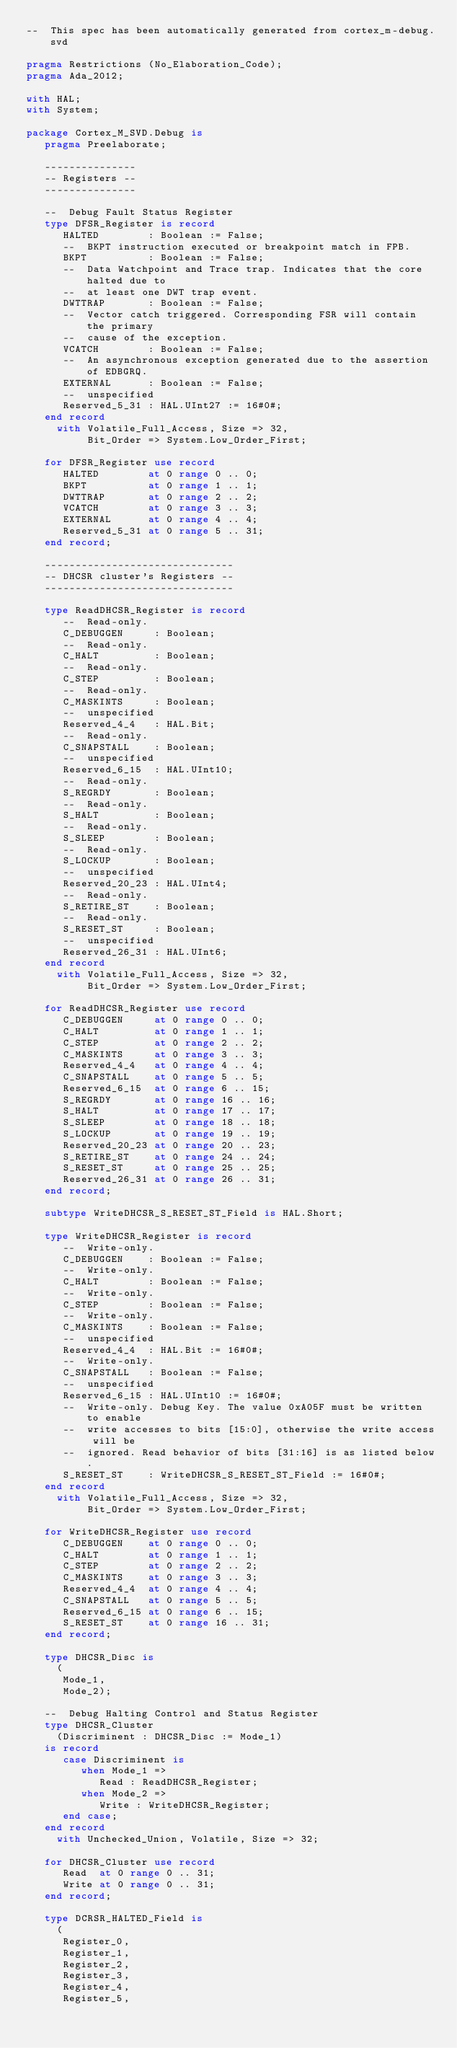Convert code to text. <code><loc_0><loc_0><loc_500><loc_500><_Ada_>--  This spec has been automatically generated from cortex_m-debug.svd

pragma Restrictions (No_Elaboration_Code);
pragma Ada_2012;

with HAL;
with System;

package Cortex_M_SVD.Debug is
   pragma Preelaborate;

   ---------------
   -- Registers --
   ---------------

   --  Debug Fault Status Register
   type DFSR_Register is record
      HALTED        : Boolean := False;
      --  BKPT instruction executed or breakpoint match in FPB.
      BKPT          : Boolean := False;
      --  Data Watchpoint and Trace trap. Indicates that the core halted due to
      --  at least one DWT trap event.
      DWTTRAP       : Boolean := False;
      --  Vector catch triggered. Corresponding FSR will contain the primary
      --  cause of the exception.
      VCATCH        : Boolean := False;
      --  An asynchronous exception generated due to the assertion of EDBGRQ.
      EXTERNAL      : Boolean := False;
      --  unspecified
      Reserved_5_31 : HAL.UInt27 := 16#0#;
   end record
     with Volatile_Full_Access, Size => 32,
          Bit_Order => System.Low_Order_First;

   for DFSR_Register use record
      HALTED        at 0 range 0 .. 0;
      BKPT          at 0 range 1 .. 1;
      DWTTRAP       at 0 range 2 .. 2;
      VCATCH        at 0 range 3 .. 3;
      EXTERNAL      at 0 range 4 .. 4;
      Reserved_5_31 at 0 range 5 .. 31;
   end record;

   -------------------------------
   -- DHCSR cluster's Registers --
   -------------------------------

   type ReadDHCSR_Register is record
      --  Read-only.
      C_DEBUGGEN     : Boolean;
      --  Read-only.
      C_HALT         : Boolean;
      --  Read-only.
      C_STEP         : Boolean;
      --  Read-only.
      C_MASKINTS     : Boolean;
      --  unspecified
      Reserved_4_4   : HAL.Bit;
      --  Read-only.
      C_SNAPSTALL    : Boolean;
      --  unspecified
      Reserved_6_15  : HAL.UInt10;
      --  Read-only.
      S_REGRDY       : Boolean;
      --  Read-only.
      S_HALT         : Boolean;
      --  Read-only.
      S_SLEEP        : Boolean;
      --  Read-only.
      S_LOCKUP       : Boolean;
      --  unspecified
      Reserved_20_23 : HAL.UInt4;
      --  Read-only.
      S_RETIRE_ST    : Boolean;
      --  Read-only.
      S_RESET_ST     : Boolean;
      --  unspecified
      Reserved_26_31 : HAL.UInt6;
   end record
     with Volatile_Full_Access, Size => 32,
          Bit_Order => System.Low_Order_First;

   for ReadDHCSR_Register use record
      C_DEBUGGEN     at 0 range 0 .. 0;
      C_HALT         at 0 range 1 .. 1;
      C_STEP         at 0 range 2 .. 2;
      C_MASKINTS     at 0 range 3 .. 3;
      Reserved_4_4   at 0 range 4 .. 4;
      C_SNAPSTALL    at 0 range 5 .. 5;
      Reserved_6_15  at 0 range 6 .. 15;
      S_REGRDY       at 0 range 16 .. 16;
      S_HALT         at 0 range 17 .. 17;
      S_SLEEP        at 0 range 18 .. 18;
      S_LOCKUP       at 0 range 19 .. 19;
      Reserved_20_23 at 0 range 20 .. 23;
      S_RETIRE_ST    at 0 range 24 .. 24;
      S_RESET_ST     at 0 range 25 .. 25;
      Reserved_26_31 at 0 range 26 .. 31;
   end record;

   subtype WriteDHCSR_S_RESET_ST_Field is HAL.Short;

   type WriteDHCSR_Register is record
      --  Write-only.
      C_DEBUGGEN    : Boolean := False;
      --  Write-only.
      C_HALT        : Boolean := False;
      --  Write-only.
      C_STEP        : Boolean := False;
      --  Write-only.
      C_MASKINTS    : Boolean := False;
      --  unspecified
      Reserved_4_4  : HAL.Bit := 16#0#;
      --  Write-only.
      C_SNAPSTALL   : Boolean := False;
      --  unspecified
      Reserved_6_15 : HAL.UInt10 := 16#0#;
      --  Write-only. Debug Key. The value 0xA05F must be written to enable
      --  write accesses to bits [15:0], otherwise the write access will be
      --  ignored. Read behavior of bits [31:16] is as listed below.
      S_RESET_ST    : WriteDHCSR_S_RESET_ST_Field := 16#0#;
   end record
     with Volatile_Full_Access, Size => 32,
          Bit_Order => System.Low_Order_First;

   for WriteDHCSR_Register use record
      C_DEBUGGEN    at 0 range 0 .. 0;
      C_HALT        at 0 range 1 .. 1;
      C_STEP        at 0 range 2 .. 2;
      C_MASKINTS    at 0 range 3 .. 3;
      Reserved_4_4  at 0 range 4 .. 4;
      C_SNAPSTALL   at 0 range 5 .. 5;
      Reserved_6_15 at 0 range 6 .. 15;
      S_RESET_ST    at 0 range 16 .. 31;
   end record;

   type DHCSR_Disc is
     (
      Mode_1,
      Mode_2);

   --  Debug Halting Control and Status Register
   type DHCSR_Cluster
     (Discriminent : DHCSR_Disc := Mode_1)
   is record
      case Discriminent is
         when Mode_1 =>
            Read : ReadDHCSR_Register;
         when Mode_2 =>
            Write : WriteDHCSR_Register;
      end case;
   end record
     with Unchecked_Union, Volatile, Size => 32;

   for DHCSR_Cluster use record
      Read  at 0 range 0 .. 31;
      Write at 0 range 0 .. 31;
   end record;

   type DCRSR_HALTED_Field is
     (
      Register_0,
      Register_1,
      Register_2,
      Register_3,
      Register_4,
      Register_5,</code> 